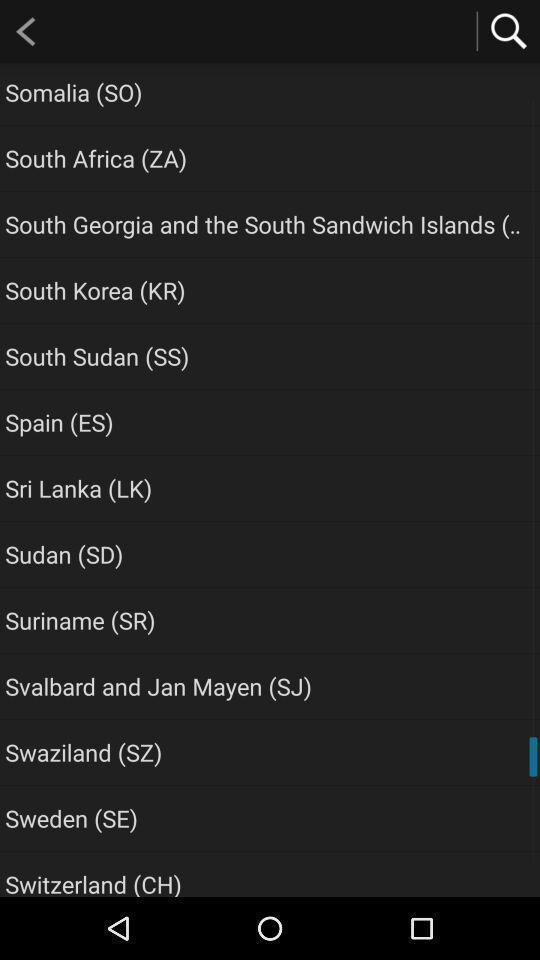What is the overall content of this screenshot? Screen shows number of location names. 